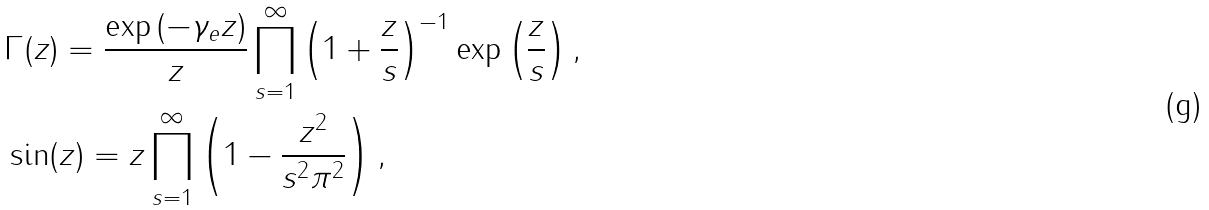Convert formula to latex. <formula><loc_0><loc_0><loc_500><loc_500>& \Gamma ( z ) = \frac { \exp \left ( - \gamma _ { e } z \right ) } { z } \prod _ { s = 1 } ^ { \infty } \left ( 1 + \frac { z } { s } \right ) ^ { - 1 } \exp \left ( \frac { z } { s } \right ) , \\ & \sin ( z ) = z \prod _ { s = 1 } ^ { \infty } \left ( 1 - \frac { z ^ { 2 } } { s ^ { 2 } \pi ^ { 2 } } \right ) ,</formula> 